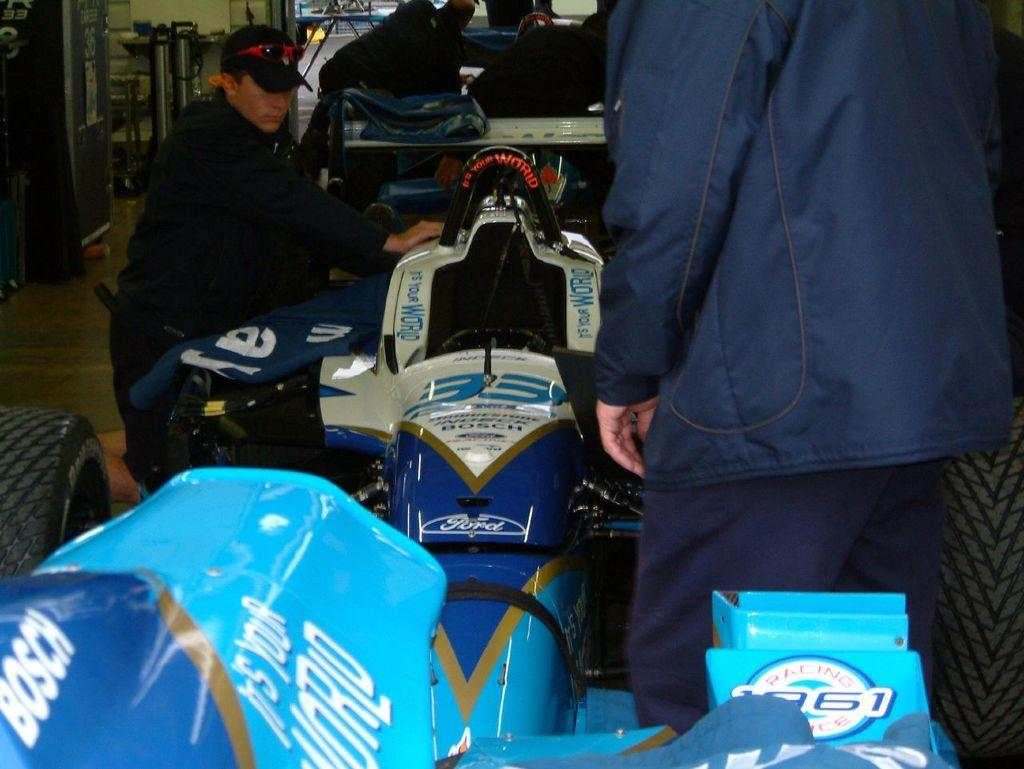What is the main subject of the image? There is a vehicle in the image. Are there any other elements present in the image besides the vehicle? Yes, there are people visible in the image. What color are the eyes of the man wearing a stocking in the image? There is no man wearing a stocking present in the image. 